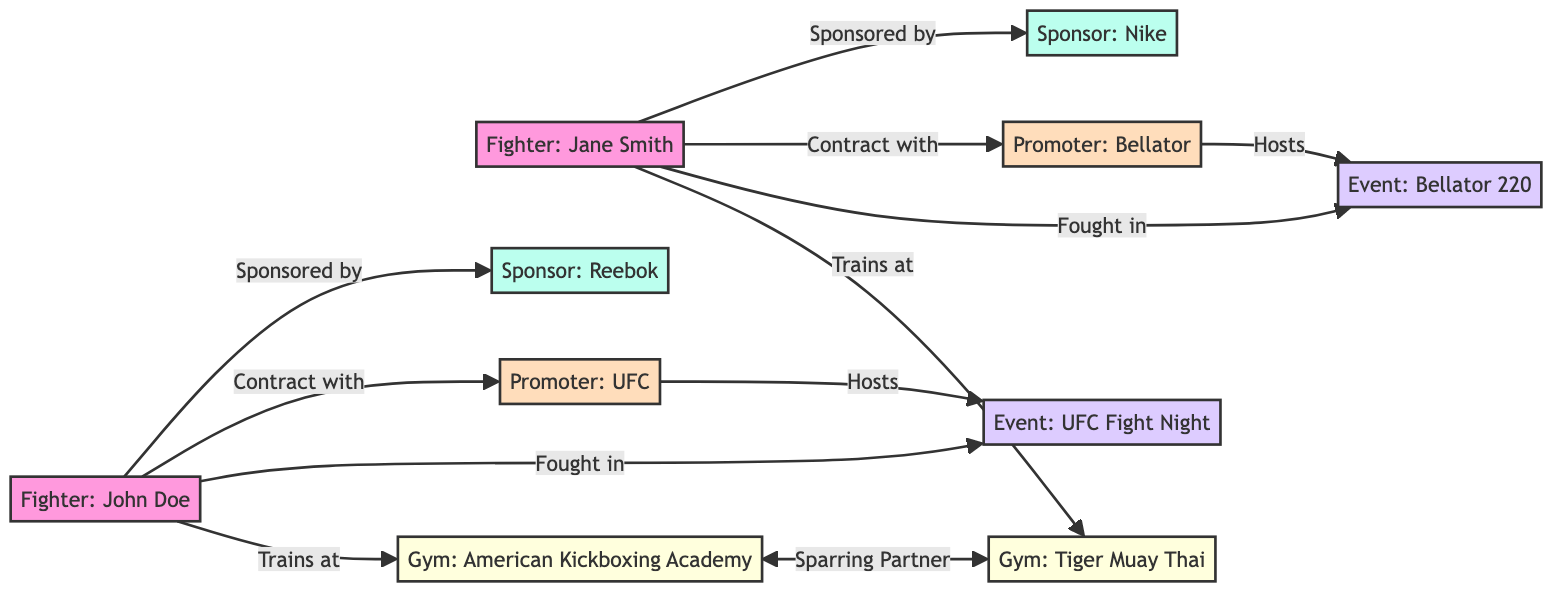What is the total number of fighters in the diagram? There are two fighter nodes in the diagram: "Fighter: John Doe" and "Fighter: Jane Smith". Counting those gives a total of 2 fighters.
Answer: 2 Which sponsor is associated with John Doe? The edge between "Fighter: John Doe" and "Sponsor: Reebok" indicates that John Doe is sponsored by Reebok.
Answer: Reebok What is the relationship between Jane Smith and Bellator? The edge labeled "Contract with" shows that "Fighter: Jane Smith" has a contractual relationship with "Promoter: Bellator".
Answer: Contract How many event organizers are represented in the diagram? The nodes for event organizers are "Event Organizer: UFC Fight Night" and "Event Organizer: Bellator 220". Therefore, the total number of event organizers is 2.
Answer: 2 What gyms do John Doe and Jane Smith train at? "Fighter: John Doe" trains at "Gym: American Kickboxing Academy" and "Fighter: Jane Smith" trains at "Gym: Tiger Muay Thai". Both gym associations can be deduced from the edges labeled "Trains at".
Answer: American Kickboxing Academy and Tiger Muay Thai Which event does UFC promote? The edge from "Promoter: UFC" to "Event Organizer: UFC Fight Night" indicates that UFC hosts this particular event.
Answer: UFC Fight Night Who are the sparring partners in the diagram? The edge between "Gym: American Kickboxing Academy" and "Gym: Tiger Muay Thai" denotes a sparring partnership. Therefore, these two gyms represent the sparring partners in the MMA community represented in the diagram.
Answer: American Kickboxing Academy and Tiger Muay Thai Which fighters are sponsored by Nike? The edge labeled "Sponsored by" shows that "Fighter: Jane Smith" is the only fighter connected to "Sponsor: Nike".
Answer: Jane Smith What edges connect the promoters to the event organizers? The edge from "Promoter: UFC" to "Event Organizer: UFC Fight Night" and the edge from "Promoter: Bellator" to "Event Organizer: Bellator 220" demonstrate the connection between promoters and their respective event organizers.
Answer: UFC Fight Night and Bellator 220 